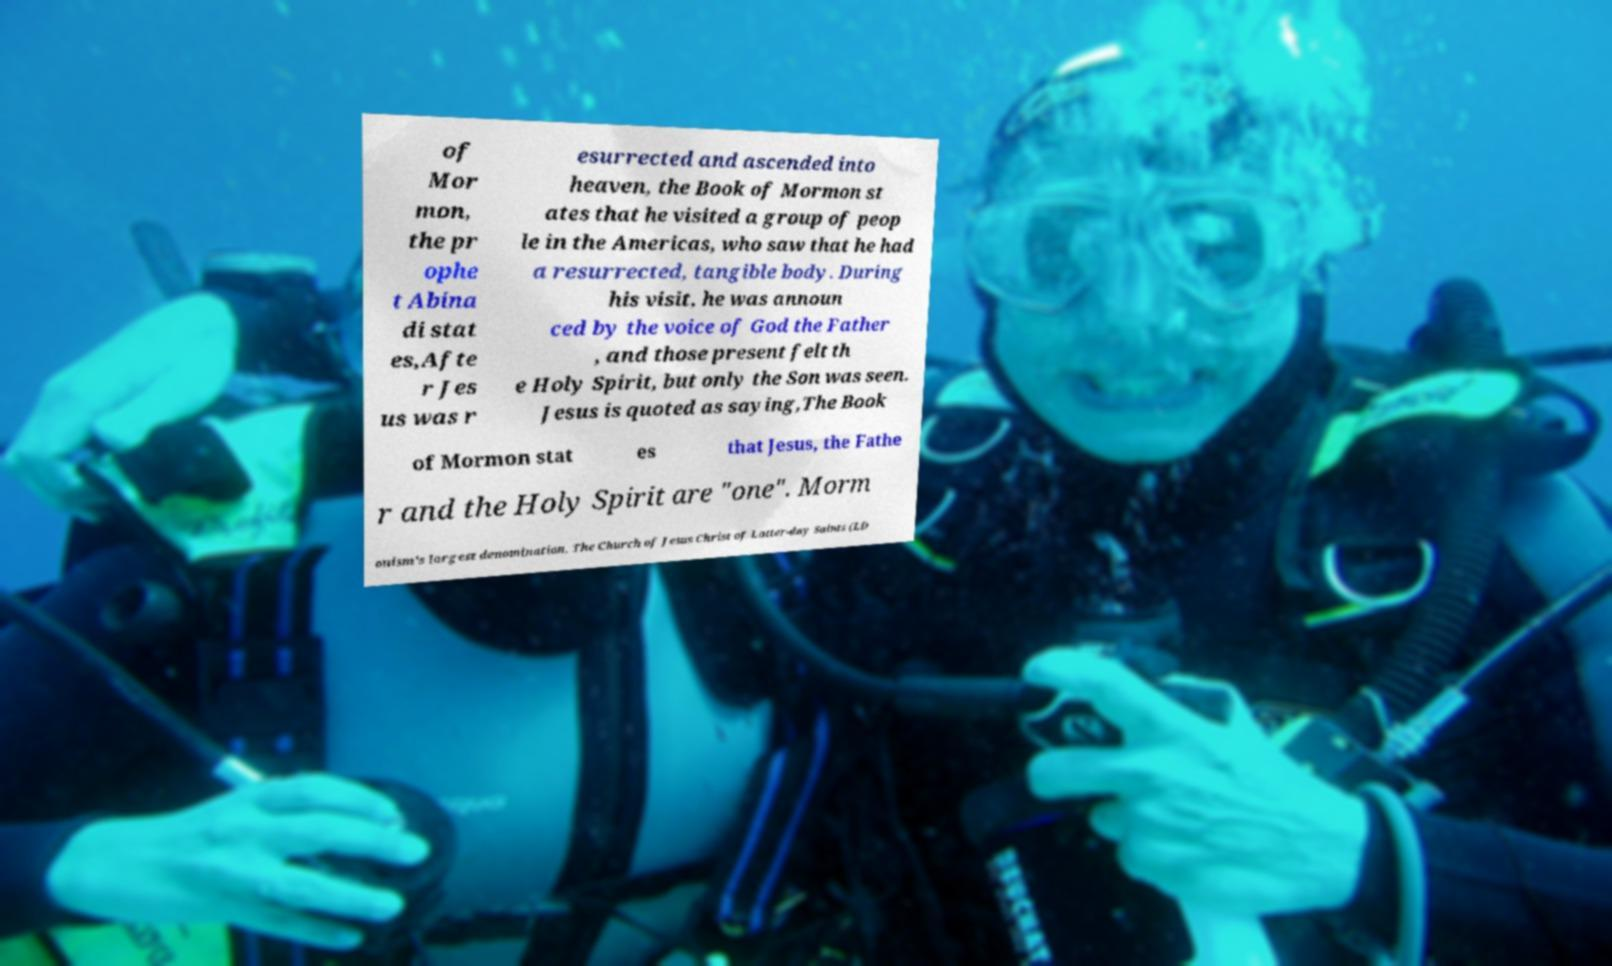Please read and relay the text visible in this image. What does it say? of Mor mon, the pr ophe t Abina di stat es,Afte r Jes us was r esurrected and ascended into heaven, the Book of Mormon st ates that he visited a group of peop le in the Americas, who saw that he had a resurrected, tangible body. During his visit, he was announ ced by the voice of God the Father , and those present felt th e Holy Spirit, but only the Son was seen. Jesus is quoted as saying,The Book of Mormon stat es that Jesus, the Fathe r and the Holy Spirit are "one". Morm onism's largest denomination, The Church of Jesus Christ of Latter-day Saints (LD 